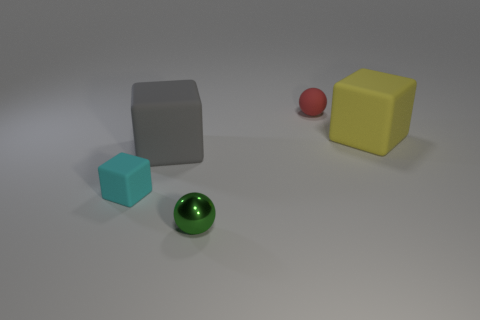Subtract all big matte blocks. How many blocks are left? 1 Add 4 big cyan cylinders. How many objects exist? 9 Subtract all balls. How many objects are left? 3 Subtract 1 cyan cubes. How many objects are left? 4 Subtract all red cubes. Subtract all red balls. How many cubes are left? 3 Subtract all brown cubes. Subtract all big gray things. How many objects are left? 4 Add 5 green spheres. How many green spheres are left? 6 Add 4 cyan cylinders. How many cyan cylinders exist? 4 